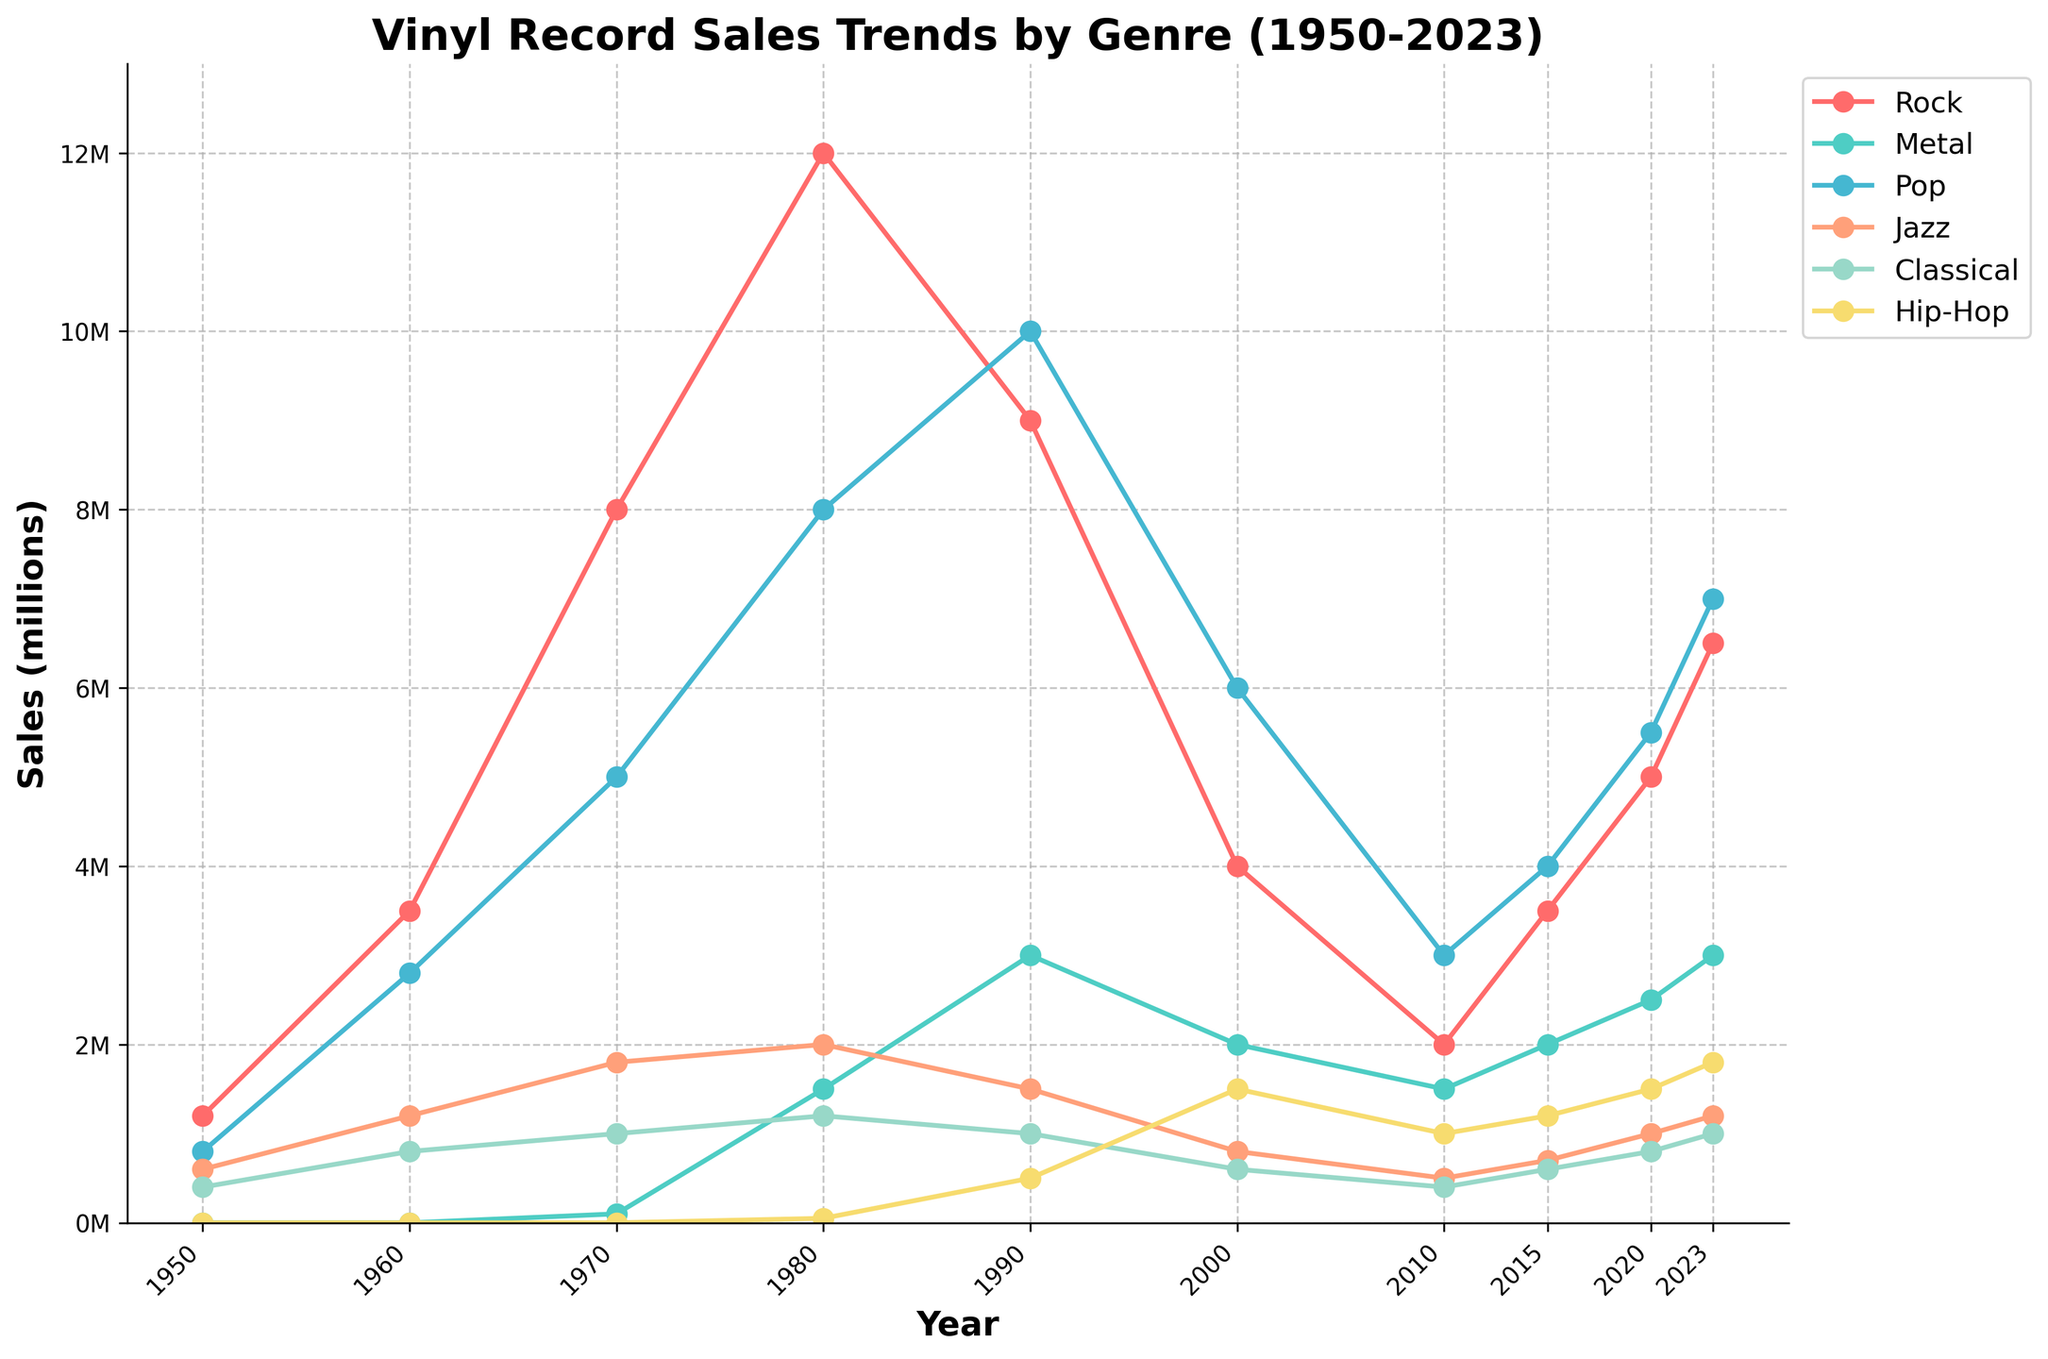Which genre had the peak sales in 1990? By looking at the plot and locating the year 1990, compare the peaks of each genre. Pop genre peaks higher than the others in 1990.
Answer: Pop What is the total sales of Metal and Jazz in 1980? Locate the values for Metal and Jazz for 1980 on the plot and sum them: Metal has 1,500,000 and Jazz has 2,000,000. Adding them gives 1,500,000 + 2,000,000 = 3,500,000.
Answer: 3,500,000 How much did Metal sales increase from 1970 to 1980? Locate the Metal sales for 1970 and 1980: 100,000 in 1970 and 1,500,000 in 1980. Subtract 100,000 from 1,500,000 to find the increase: 1,500,000 - 100,000 = 1,400,000.
Answer: 1,400,000 Between 2000 and 2020, which genre had the largest increase in sales? Calculate the difference in sales: Rock (5,000,000 - 4,000,000 = 1,000,000), Metal (2,500,000 - 2,000,000 = 500,000), Pop (5,500,000 - 6,000,000 = -500,000), Jazz (1,000,000 - 800,000 = 200,000), Classical (800,000), Hip-Hop (1,500,000 - 1,500,000 = 0). Rock shows the largest increase.
Answer: Rock In what year did Hip-Hop sales surpass 1,000,000 for the first time? Look at the Hip-Hop trend line and identify the year when it first crosses 1,000,000. The year is 2000.
Answer: 2000 Which genre had the smallest sales decrease from 1980 to 1990? Calculate the sales decrease for each genre from 1980 to 1990: Rock (12,000,000 - 9,000,000 = 3,000,000 decrease), Metal (1,500,000 increase), Pop (10,000,000 - 8,000,000 = 2,000,000 decrease), Jazz (1,500,000 - 2,000,000 = -500,000 increase), Classical (1,200,000 - 1,000,000 = -200,000 increase), Hip-Hop (450,000 increase). Jazz had the smallest decrease with no actual decrease.
Answer: Jazz How did the metal sales in 2023 compare to those in 2010? Check the Metal sales in 2010 (1,500,000) and in 2023 (3,000,000). Compare these two values: 3,000,000 is greater than 1,500,000.
Answer: Greater What is the average sales of Classical music from 1950 to 2023? Identify the values from the plot for each year: 1950 (400,000), 1960 (800,000), 1970 (1,000,000), 1980 (1,200,000), 1990 (1,000,000), 2000 (600,000), 2010 (400,000), 2015 (600,000), 2020 (800,000), 2023 (1,000,000). Sum these values and divide by the number of years: (400,000 + 800,000 + 1,000,000 + 1,200,000 + 1,000,000 + 600,000 + 400,000 + 600,000 + 800,000 + 1,000,000) / 10 = 7,800,000 / 10 = 780,000.
Answer: 780,000 From which year did Hip-Hop sales start showing a significant upward trend? Observe the Hip-Hop trend line and identify the year where a noticeable increase starts. The significant upward trend begins around 2000.
Answer: 2000 